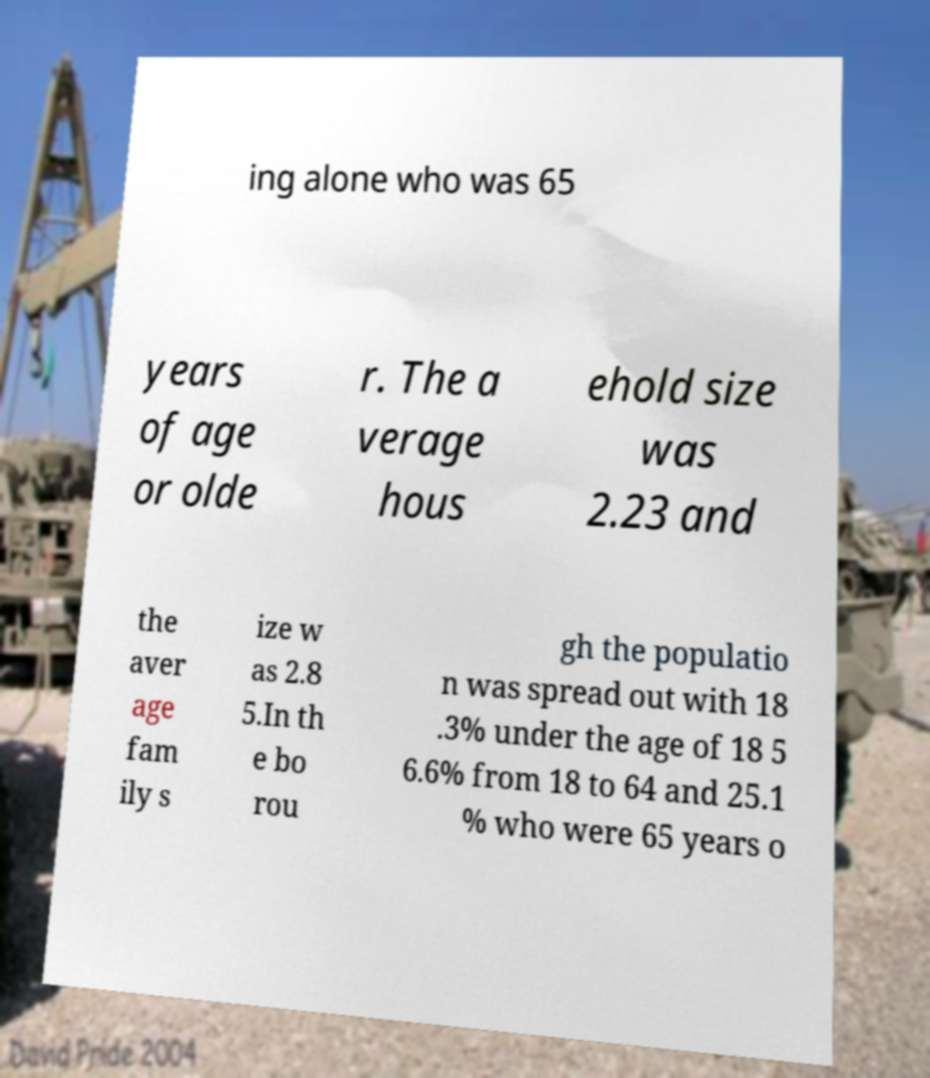I need the written content from this picture converted into text. Can you do that? ing alone who was 65 years of age or olde r. The a verage hous ehold size was 2.23 and the aver age fam ily s ize w as 2.8 5.In th e bo rou gh the populatio n was spread out with 18 .3% under the age of 18 5 6.6% from 18 to 64 and 25.1 % who were 65 years o 